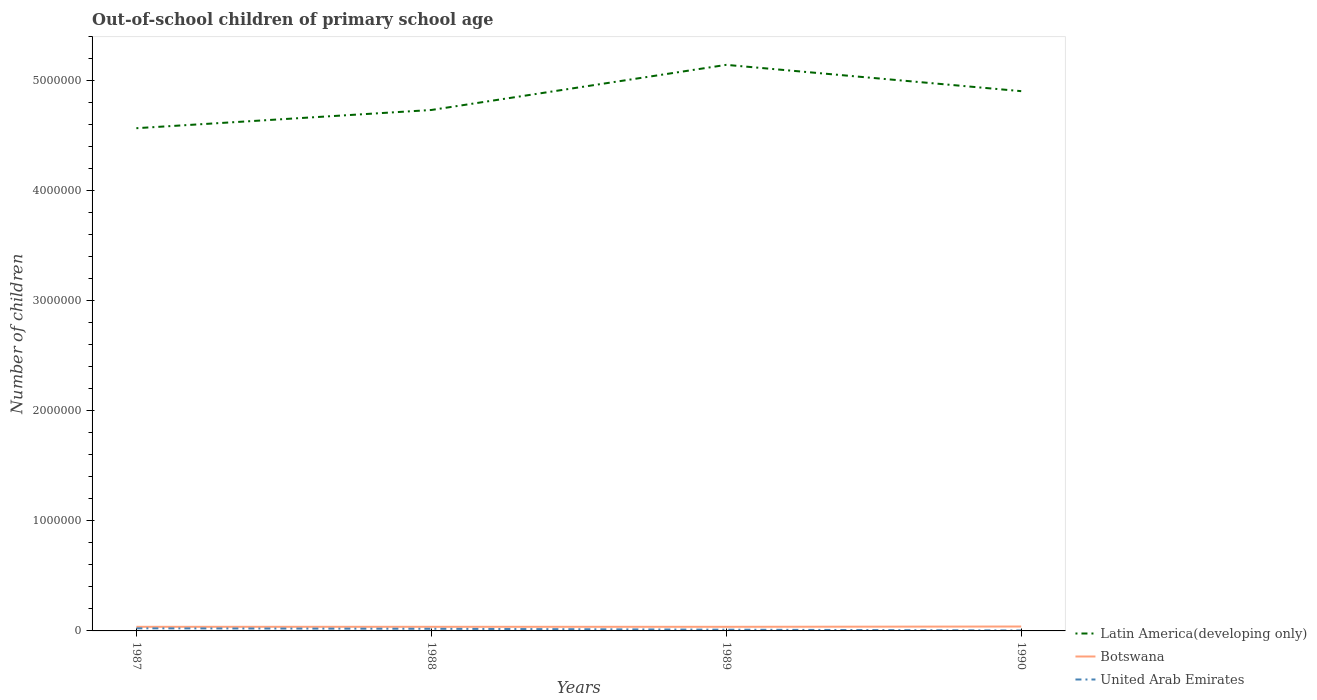Does the line corresponding to Latin America(developing only) intersect with the line corresponding to United Arab Emirates?
Your answer should be very brief. No. Is the number of lines equal to the number of legend labels?
Offer a very short reply. Yes. Across all years, what is the maximum number of out-of-school children in Botswana?
Offer a terse response. 3.74e+04. In which year was the number of out-of-school children in Latin America(developing only) maximum?
Keep it short and to the point. 1987. What is the total number of out-of-school children in Botswana in the graph?
Provide a short and direct response. 8. What is the difference between the highest and the second highest number of out-of-school children in Latin America(developing only)?
Ensure brevity in your answer.  5.76e+05. Is the number of out-of-school children in Latin America(developing only) strictly greater than the number of out-of-school children in United Arab Emirates over the years?
Ensure brevity in your answer.  No. Does the graph contain any zero values?
Give a very brief answer. No. Does the graph contain grids?
Ensure brevity in your answer.  No. What is the title of the graph?
Provide a short and direct response. Out-of-school children of primary school age. What is the label or title of the X-axis?
Offer a very short reply. Years. What is the label or title of the Y-axis?
Keep it short and to the point. Number of children. What is the Number of children in Latin America(developing only) in 1987?
Your response must be concise. 4.57e+06. What is the Number of children of Botswana in 1987?
Offer a very short reply. 3.74e+04. What is the Number of children in United Arab Emirates in 1987?
Provide a succinct answer. 2.36e+04. What is the Number of children in Latin America(developing only) in 1988?
Your answer should be very brief. 4.73e+06. What is the Number of children of Botswana in 1988?
Offer a terse response. 3.75e+04. What is the Number of children in United Arab Emirates in 1988?
Provide a short and direct response. 1.92e+04. What is the Number of children in Latin America(developing only) in 1989?
Offer a very short reply. 5.14e+06. What is the Number of children of Botswana in 1989?
Provide a short and direct response. 3.74e+04. What is the Number of children in United Arab Emirates in 1989?
Provide a short and direct response. 1.13e+04. What is the Number of children of Latin America(developing only) in 1990?
Your answer should be compact. 4.91e+06. What is the Number of children in Botswana in 1990?
Your response must be concise. 4.00e+04. What is the Number of children of United Arab Emirates in 1990?
Ensure brevity in your answer.  3948. Across all years, what is the maximum Number of children of Latin America(developing only)?
Offer a very short reply. 5.14e+06. Across all years, what is the maximum Number of children in Botswana?
Make the answer very short. 4.00e+04. Across all years, what is the maximum Number of children of United Arab Emirates?
Provide a succinct answer. 2.36e+04. Across all years, what is the minimum Number of children in Latin America(developing only)?
Provide a short and direct response. 4.57e+06. Across all years, what is the minimum Number of children in Botswana?
Offer a terse response. 3.74e+04. Across all years, what is the minimum Number of children of United Arab Emirates?
Give a very brief answer. 3948. What is the total Number of children of Latin America(developing only) in the graph?
Offer a terse response. 1.94e+07. What is the total Number of children of Botswana in the graph?
Offer a terse response. 1.52e+05. What is the total Number of children of United Arab Emirates in the graph?
Ensure brevity in your answer.  5.81e+04. What is the difference between the Number of children in Latin America(developing only) in 1987 and that in 1988?
Your response must be concise. -1.66e+05. What is the difference between the Number of children in Botswana in 1987 and that in 1988?
Provide a succinct answer. -164. What is the difference between the Number of children in United Arab Emirates in 1987 and that in 1988?
Provide a succinct answer. 4380. What is the difference between the Number of children of Latin America(developing only) in 1987 and that in 1989?
Provide a succinct answer. -5.76e+05. What is the difference between the Number of children in Botswana in 1987 and that in 1989?
Provide a succinct answer. 8. What is the difference between the Number of children in United Arab Emirates in 1987 and that in 1989?
Offer a very short reply. 1.23e+04. What is the difference between the Number of children of Latin America(developing only) in 1987 and that in 1990?
Make the answer very short. -3.37e+05. What is the difference between the Number of children in Botswana in 1987 and that in 1990?
Your response must be concise. -2612. What is the difference between the Number of children of United Arab Emirates in 1987 and that in 1990?
Ensure brevity in your answer.  1.97e+04. What is the difference between the Number of children in Latin America(developing only) in 1988 and that in 1989?
Ensure brevity in your answer.  -4.10e+05. What is the difference between the Number of children in Botswana in 1988 and that in 1989?
Give a very brief answer. 172. What is the difference between the Number of children in United Arab Emirates in 1988 and that in 1989?
Your response must be concise. 7911. What is the difference between the Number of children of Latin America(developing only) in 1988 and that in 1990?
Your answer should be very brief. -1.71e+05. What is the difference between the Number of children of Botswana in 1988 and that in 1990?
Make the answer very short. -2448. What is the difference between the Number of children of United Arab Emirates in 1988 and that in 1990?
Your answer should be compact. 1.53e+04. What is the difference between the Number of children of Latin America(developing only) in 1989 and that in 1990?
Provide a succinct answer. 2.39e+05. What is the difference between the Number of children of Botswana in 1989 and that in 1990?
Your answer should be very brief. -2620. What is the difference between the Number of children in United Arab Emirates in 1989 and that in 1990?
Make the answer very short. 7385. What is the difference between the Number of children in Latin America(developing only) in 1987 and the Number of children in Botswana in 1988?
Offer a terse response. 4.53e+06. What is the difference between the Number of children in Latin America(developing only) in 1987 and the Number of children in United Arab Emirates in 1988?
Make the answer very short. 4.55e+06. What is the difference between the Number of children in Botswana in 1987 and the Number of children in United Arab Emirates in 1988?
Provide a short and direct response. 1.81e+04. What is the difference between the Number of children of Latin America(developing only) in 1987 and the Number of children of Botswana in 1989?
Keep it short and to the point. 4.53e+06. What is the difference between the Number of children of Latin America(developing only) in 1987 and the Number of children of United Arab Emirates in 1989?
Make the answer very short. 4.56e+06. What is the difference between the Number of children of Botswana in 1987 and the Number of children of United Arab Emirates in 1989?
Make the answer very short. 2.60e+04. What is the difference between the Number of children in Latin America(developing only) in 1987 and the Number of children in Botswana in 1990?
Offer a very short reply. 4.53e+06. What is the difference between the Number of children in Latin America(developing only) in 1987 and the Number of children in United Arab Emirates in 1990?
Provide a succinct answer. 4.57e+06. What is the difference between the Number of children of Botswana in 1987 and the Number of children of United Arab Emirates in 1990?
Your response must be concise. 3.34e+04. What is the difference between the Number of children of Latin America(developing only) in 1988 and the Number of children of Botswana in 1989?
Make the answer very short. 4.70e+06. What is the difference between the Number of children in Latin America(developing only) in 1988 and the Number of children in United Arab Emirates in 1989?
Provide a short and direct response. 4.72e+06. What is the difference between the Number of children in Botswana in 1988 and the Number of children in United Arab Emirates in 1989?
Offer a very short reply. 2.62e+04. What is the difference between the Number of children in Latin America(developing only) in 1988 and the Number of children in Botswana in 1990?
Your answer should be very brief. 4.69e+06. What is the difference between the Number of children in Latin America(developing only) in 1988 and the Number of children in United Arab Emirates in 1990?
Your answer should be very brief. 4.73e+06. What is the difference between the Number of children of Botswana in 1988 and the Number of children of United Arab Emirates in 1990?
Give a very brief answer. 3.36e+04. What is the difference between the Number of children of Latin America(developing only) in 1989 and the Number of children of Botswana in 1990?
Provide a short and direct response. 5.10e+06. What is the difference between the Number of children in Latin America(developing only) in 1989 and the Number of children in United Arab Emirates in 1990?
Give a very brief answer. 5.14e+06. What is the difference between the Number of children of Botswana in 1989 and the Number of children of United Arab Emirates in 1990?
Provide a short and direct response. 3.34e+04. What is the average Number of children in Latin America(developing only) per year?
Offer a terse response. 4.84e+06. What is the average Number of children of Botswana per year?
Your answer should be compact. 3.81e+04. What is the average Number of children of United Arab Emirates per year?
Your response must be concise. 1.45e+04. In the year 1987, what is the difference between the Number of children in Latin America(developing only) and Number of children in Botswana?
Your answer should be very brief. 4.53e+06. In the year 1987, what is the difference between the Number of children of Latin America(developing only) and Number of children of United Arab Emirates?
Your answer should be compact. 4.55e+06. In the year 1987, what is the difference between the Number of children of Botswana and Number of children of United Arab Emirates?
Your answer should be compact. 1.37e+04. In the year 1988, what is the difference between the Number of children in Latin America(developing only) and Number of children in Botswana?
Offer a terse response. 4.70e+06. In the year 1988, what is the difference between the Number of children of Latin America(developing only) and Number of children of United Arab Emirates?
Make the answer very short. 4.72e+06. In the year 1988, what is the difference between the Number of children of Botswana and Number of children of United Arab Emirates?
Your response must be concise. 1.83e+04. In the year 1989, what is the difference between the Number of children of Latin America(developing only) and Number of children of Botswana?
Keep it short and to the point. 5.11e+06. In the year 1989, what is the difference between the Number of children in Latin America(developing only) and Number of children in United Arab Emirates?
Offer a very short reply. 5.13e+06. In the year 1989, what is the difference between the Number of children of Botswana and Number of children of United Arab Emirates?
Offer a very short reply. 2.60e+04. In the year 1990, what is the difference between the Number of children in Latin America(developing only) and Number of children in Botswana?
Keep it short and to the point. 4.87e+06. In the year 1990, what is the difference between the Number of children in Latin America(developing only) and Number of children in United Arab Emirates?
Provide a succinct answer. 4.90e+06. In the year 1990, what is the difference between the Number of children of Botswana and Number of children of United Arab Emirates?
Provide a short and direct response. 3.60e+04. What is the ratio of the Number of children of Latin America(developing only) in 1987 to that in 1988?
Your response must be concise. 0.96. What is the ratio of the Number of children in United Arab Emirates in 1987 to that in 1988?
Your answer should be compact. 1.23. What is the ratio of the Number of children in Latin America(developing only) in 1987 to that in 1989?
Your response must be concise. 0.89. What is the ratio of the Number of children of Botswana in 1987 to that in 1989?
Keep it short and to the point. 1. What is the ratio of the Number of children of United Arab Emirates in 1987 to that in 1989?
Offer a terse response. 2.08. What is the ratio of the Number of children in Latin America(developing only) in 1987 to that in 1990?
Keep it short and to the point. 0.93. What is the ratio of the Number of children in Botswana in 1987 to that in 1990?
Your answer should be very brief. 0.93. What is the ratio of the Number of children in United Arab Emirates in 1987 to that in 1990?
Your response must be concise. 5.98. What is the ratio of the Number of children of Latin America(developing only) in 1988 to that in 1989?
Provide a succinct answer. 0.92. What is the ratio of the Number of children of Botswana in 1988 to that in 1989?
Your response must be concise. 1. What is the ratio of the Number of children of United Arab Emirates in 1988 to that in 1989?
Keep it short and to the point. 1.7. What is the ratio of the Number of children of Latin America(developing only) in 1988 to that in 1990?
Keep it short and to the point. 0.97. What is the ratio of the Number of children in Botswana in 1988 to that in 1990?
Your answer should be very brief. 0.94. What is the ratio of the Number of children of United Arab Emirates in 1988 to that in 1990?
Provide a short and direct response. 4.87. What is the ratio of the Number of children in Latin America(developing only) in 1989 to that in 1990?
Offer a terse response. 1.05. What is the ratio of the Number of children of Botswana in 1989 to that in 1990?
Ensure brevity in your answer.  0.93. What is the ratio of the Number of children of United Arab Emirates in 1989 to that in 1990?
Your response must be concise. 2.87. What is the difference between the highest and the second highest Number of children in Latin America(developing only)?
Give a very brief answer. 2.39e+05. What is the difference between the highest and the second highest Number of children in Botswana?
Offer a very short reply. 2448. What is the difference between the highest and the second highest Number of children in United Arab Emirates?
Make the answer very short. 4380. What is the difference between the highest and the lowest Number of children of Latin America(developing only)?
Your answer should be very brief. 5.76e+05. What is the difference between the highest and the lowest Number of children of Botswana?
Give a very brief answer. 2620. What is the difference between the highest and the lowest Number of children of United Arab Emirates?
Make the answer very short. 1.97e+04. 